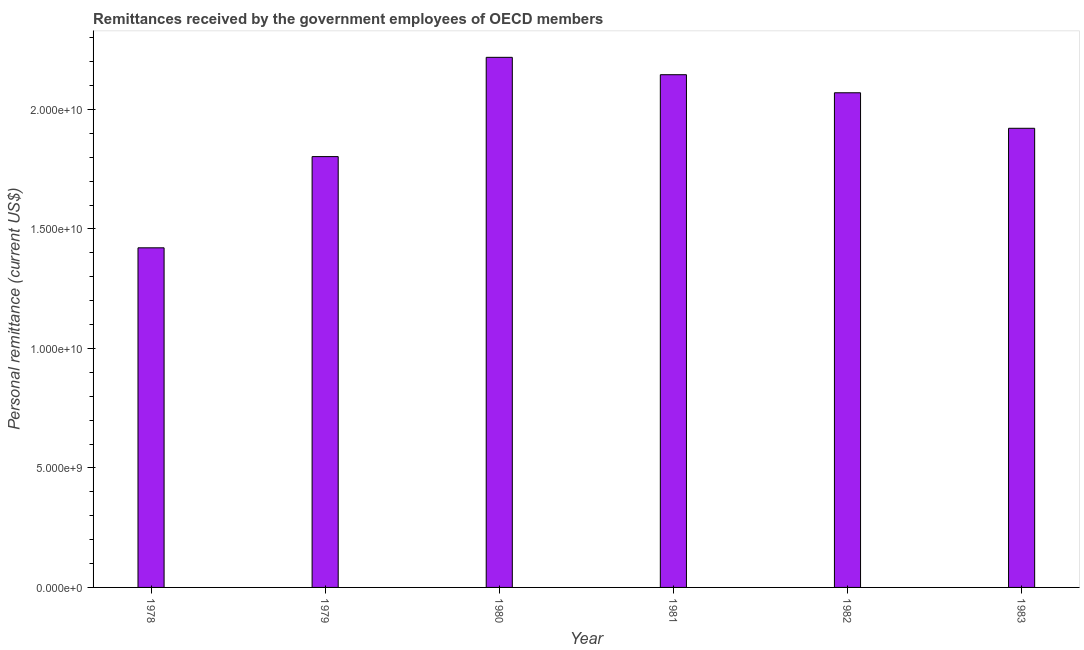What is the title of the graph?
Your answer should be compact. Remittances received by the government employees of OECD members. What is the label or title of the X-axis?
Keep it short and to the point. Year. What is the label or title of the Y-axis?
Your answer should be very brief. Personal remittance (current US$). What is the personal remittances in 1981?
Your response must be concise. 2.15e+1. Across all years, what is the maximum personal remittances?
Provide a succinct answer. 2.22e+1. Across all years, what is the minimum personal remittances?
Ensure brevity in your answer.  1.42e+1. In which year was the personal remittances maximum?
Ensure brevity in your answer.  1980. In which year was the personal remittances minimum?
Keep it short and to the point. 1978. What is the sum of the personal remittances?
Give a very brief answer. 1.16e+11. What is the difference between the personal remittances in 1979 and 1981?
Your response must be concise. -3.43e+09. What is the average personal remittances per year?
Provide a succinct answer. 1.93e+1. What is the median personal remittances?
Offer a very short reply. 2.00e+1. Do a majority of the years between 1978 and 1981 (inclusive) have personal remittances greater than 19000000000 US$?
Your response must be concise. No. What is the ratio of the personal remittances in 1980 to that in 1983?
Provide a succinct answer. 1.16. Is the personal remittances in 1978 less than that in 1981?
Your answer should be very brief. Yes. Is the difference between the personal remittances in 1979 and 1980 greater than the difference between any two years?
Provide a short and direct response. No. What is the difference between the highest and the second highest personal remittances?
Ensure brevity in your answer.  7.27e+08. Is the sum of the personal remittances in 1980 and 1982 greater than the maximum personal remittances across all years?
Make the answer very short. Yes. What is the difference between the highest and the lowest personal remittances?
Give a very brief answer. 7.97e+09. How many years are there in the graph?
Make the answer very short. 6. Are the values on the major ticks of Y-axis written in scientific E-notation?
Keep it short and to the point. Yes. What is the Personal remittance (current US$) of 1978?
Give a very brief answer. 1.42e+1. What is the Personal remittance (current US$) in 1979?
Your answer should be very brief. 1.80e+1. What is the Personal remittance (current US$) of 1980?
Make the answer very short. 2.22e+1. What is the Personal remittance (current US$) of 1981?
Make the answer very short. 2.15e+1. What is the Personal remittance (current US$) in 1982?
Offer a very short reply. 2.07e+1. What is the Personal remittance (current US$) of 1983?
Offer a terse response. 1.92e+1. What is the difference between the Personal remittance (current US$) in 1978 and 1979?
Give a very brief answer. -3.82e+09. What is the difference between the Personal remittance (current US$) in 1978 and 1980?
Provide a short and direct response. -7.97e+09. What is the difference between the Personal remittance (current US$) in 1978 and 1981?
Your response must be concise. -7.24e+09. What is the difference between the Personal remittance (current US$) in 1978 and 1982?
Your answer should be very brief. -6.49e+09. What is the difference between the Personal remittance (current US$) in 1978 and 1983?
Provide a succinct answer. -5.00e+09. What is the difference between the Personal remittance (current US$) in 1979 and 1980?
Offer a terse response. -4.15e+09. What is the difference between the Personal remittance (current US$) in 1979 and 1981?
Make the answer very short. -3.43e+09. What is the difference between the Personal remittance (current US$) in 1979 and 1982?
Provide a succinct answer. -2.67e+09. What is the difference between the Personal remittance (current US$) in 1979 and 1983?
Provide a succinct answer. -1.18e+09. What is the difference between the Personal remittance (current US$) in 1980 and 1981?
Offer a very short reply. 7.27e+08. What is the difference between the Personal remittance (current US$) in 1980 and 1982?
Give a very brief answer. 1.48e+09. What is the difference between the Personal remittance (current US$) in 1980 and 1983?
Your answer should be compact. 2.97e+09. What is the difference between the Personal remittance (current US$) in 1981 and 1982?
Offer a terse response. 7.56e+08. What is the difference between the Personal remittance (current US$) in 1981 and 1983?
Your response must be concise. 2.24e+09. What is the difference between the Personal remittance (current US$) in 1982 and 1983?
Your answer should be compact. 1.49e+09. What is the ratio of the Personal remittance (current US$) in 1978 to that in 1979?
Your response must be concise. 0.79. What is the ratio of the Personal remittance (current US$) in 1978 to that in 1980?
Give a very brief answer. 0.64. What is the ratio of the Personal remittance (current US$) in 1978 to that in 1981?
Give a very brief answer. 0.66. What is the ratio of the Personal remittance (current US$) in 1978 to that in 1982?
Provide a succinct answer. 0.69. What is the ratio of the Personal remittance (current US$) in 1978 to that in 1983?
Give a very brief answer. 0.74. What is the ratio of the Personal remittance (current US$) in 1979 to that in 1980?
Provide a succinct answer. 0.81. What is the ratio of the Personal remittance (current US$) in 1979 to that in 1981?
Keep it short and to the point. 0.84. What is the ratio of the Personal remittance (current US$) in 1979 to that in 1982?
Your response must be concise. 0.87. What is the ratio of the Personal remittance (current US$) in 1979 to that in 1983?
Your response must be concise. 0.94. What is the ratio of the Personal remittance (current US$) in 1980 to that in 1981?
Keep it short and to the point. 1.03. What is the ratio of the Personal remittance (current US$) in 1980 to that in 1982?
Provide a short and direct response. 1.07. What is the ratio of the Personal remittance (current US$) in 1980 to that in 1983?
Keep it short and to the point. 1.16. What is the ratio of the Personal remittance (current US$) in 1981 to that in 1983?
Provide a succinct answer. 1.12. What is the ratio of the Personal remittance (current US$) in 1982 to that in 1983?
Ensure brevity in your answer.  1.08. 